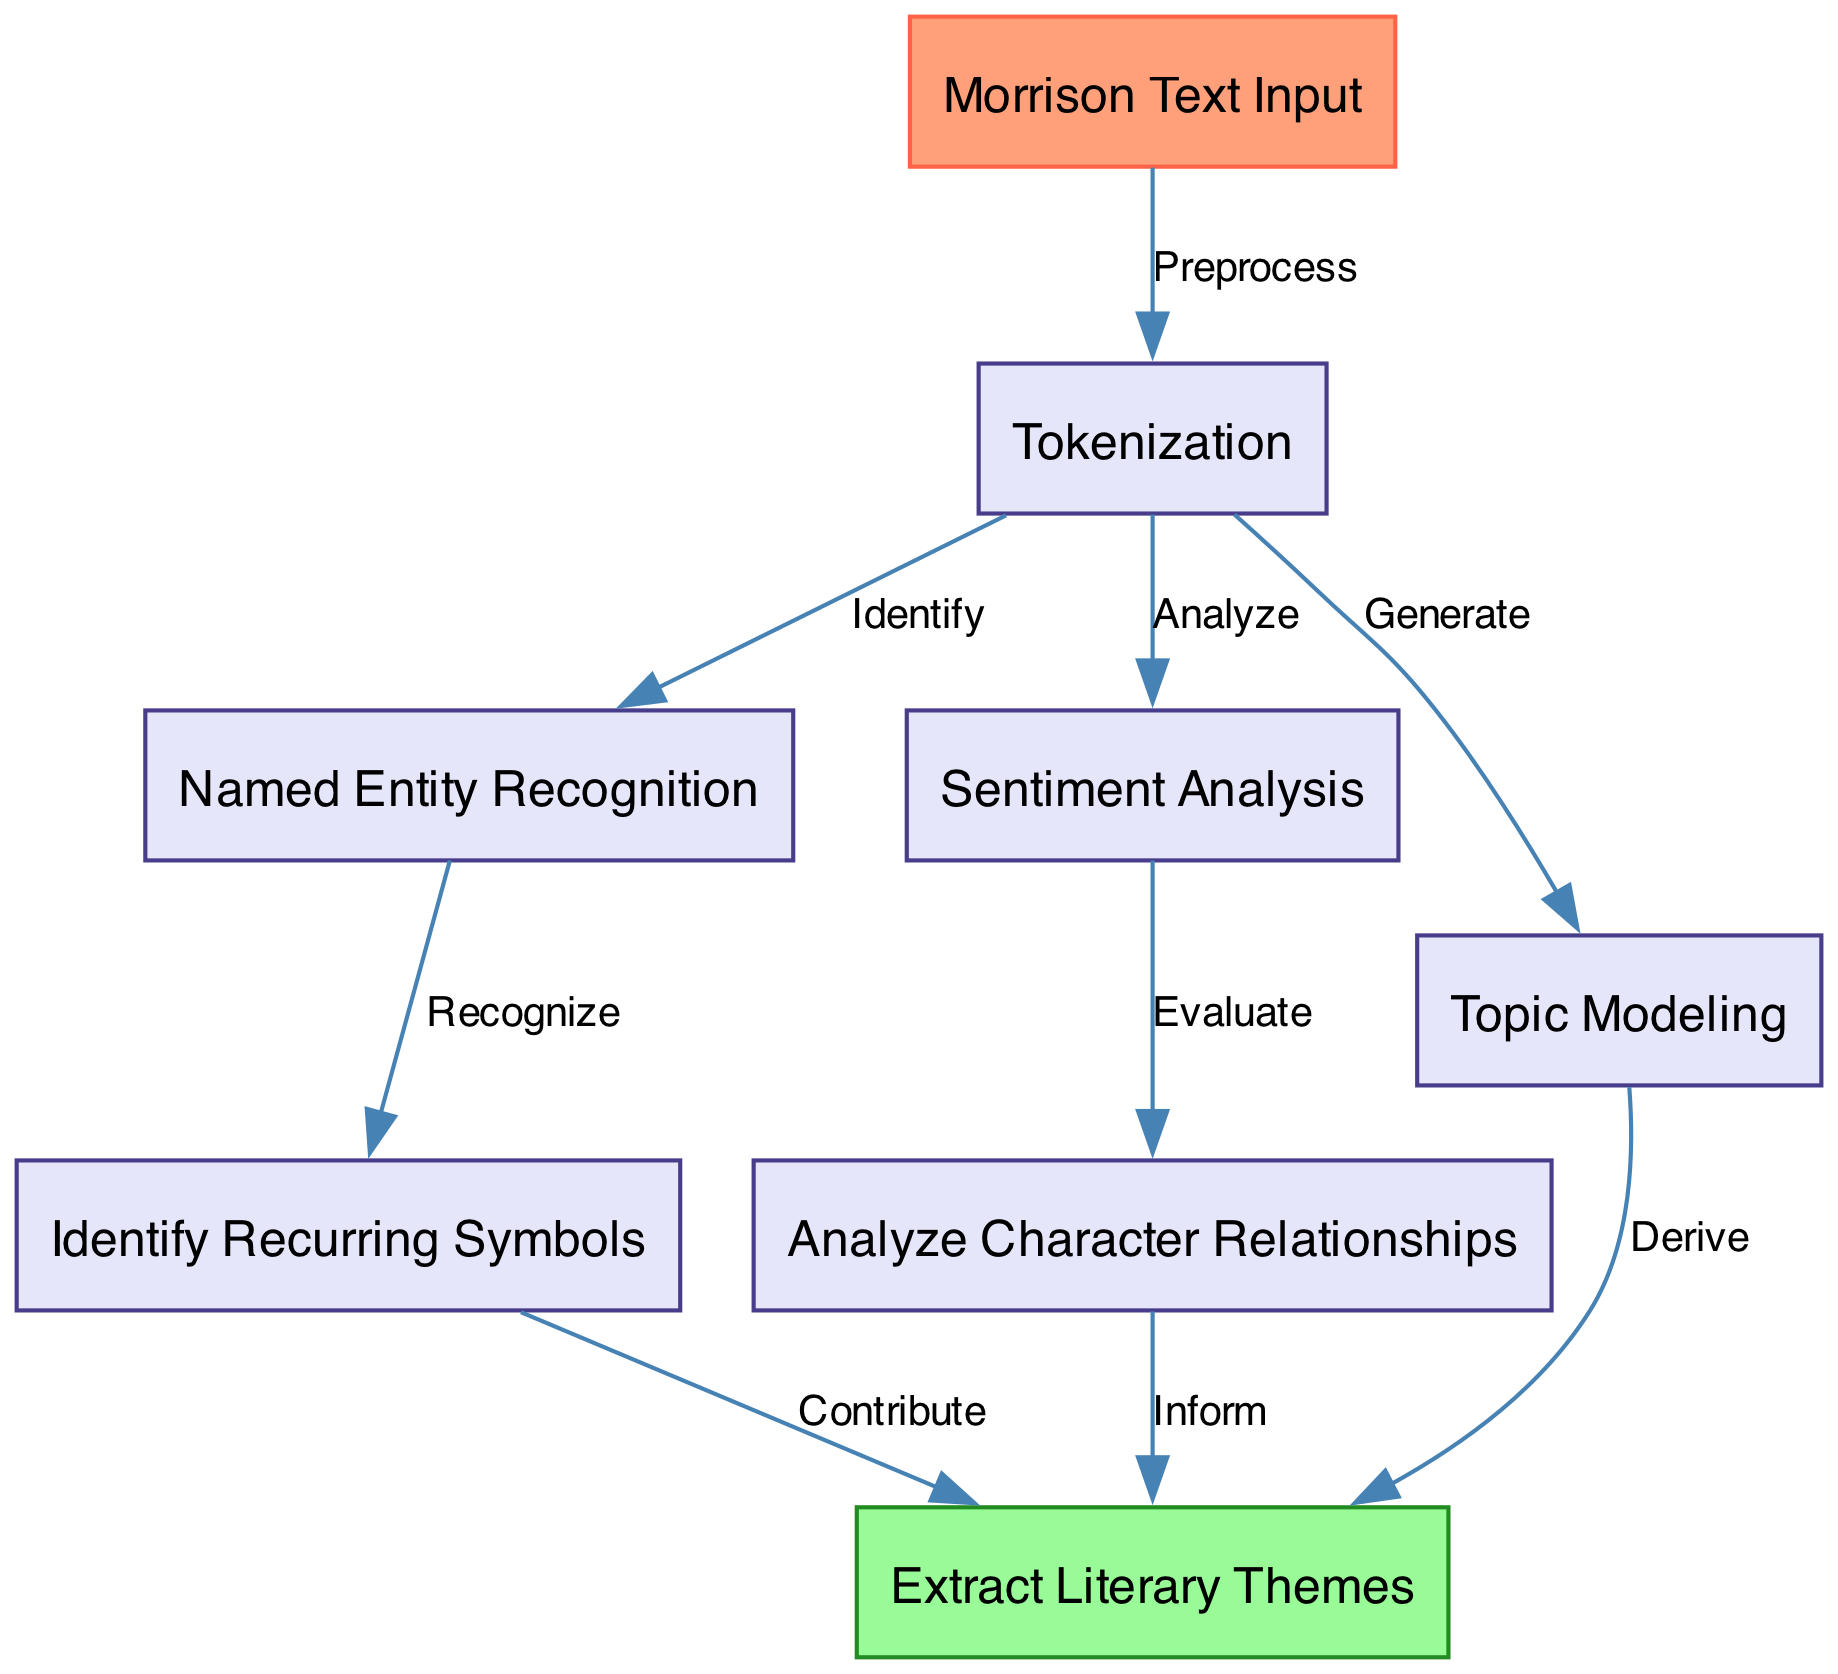What is the first node in the diagram? The first node in the diagram is labeled "Morrison Text Input", which is the starting point for text analysis techniques.
Answer: Morrison Text Input How many nodes are present in the diagram? By counting the unique labels in the nodes section of the diagram, there are a total of eight distinct nodes.
Answer: 8 What type of analysis follows Tokenization? According to the diagram, the analysis following Tokenization includes Named Entity Recognition, Sentiment Analysis, and Topic Modeling, but specifically, the next node is Named Entity Recognition.
Answer: Named Entity Recognition Which node is the endpoint in the diagram? The endpoint in the diagram is labeled "Extract Literary Themes", which represents the final outcome of the analysis flow.
Answer: Extract Literary Themes What is the relationship between "Sentiment Analysis" and "Analyze Character Relationships"? The relationship is established through the edges leading out of Sentiment Analysis directly to "Analyze Character Relationships" via its evaluation process, but there is no direct edge between the two; thus, they are only connected indirectly through the final node of "Extract Literary Themes".
Answer: Indirect connection Which two nodes directly contribute to "Extract Literary Themes"? The nodes that directly contribute to "Extract Literary Themes" are "Topic Modeling" and "Identify Recurring Symbols", which both feed into the extraction of literary themes.
Answer: Topic Modeling and Identify Recurring Symbols What labels are used for the edges leading from "Tokenization"? The labels for the edges leading from "Tokenization" are "Identify" for Named Entity Recognition, "Analyze" for Sentiment Analysis, and "Generate" for Topic Modeling, indicating various processing steps after tokenization.
Answer: Identify, Analyze, Generate What does the edge labeled "Contribute" signify in the context of the diagram? The edge labeled "Contribute" signifies that the output from the "Identify Recurring Symbols" node directly adds to or enhances the final output of "Extract Literary Themes", indicating collaborative information processing.
Answer: Collaborative information processing 